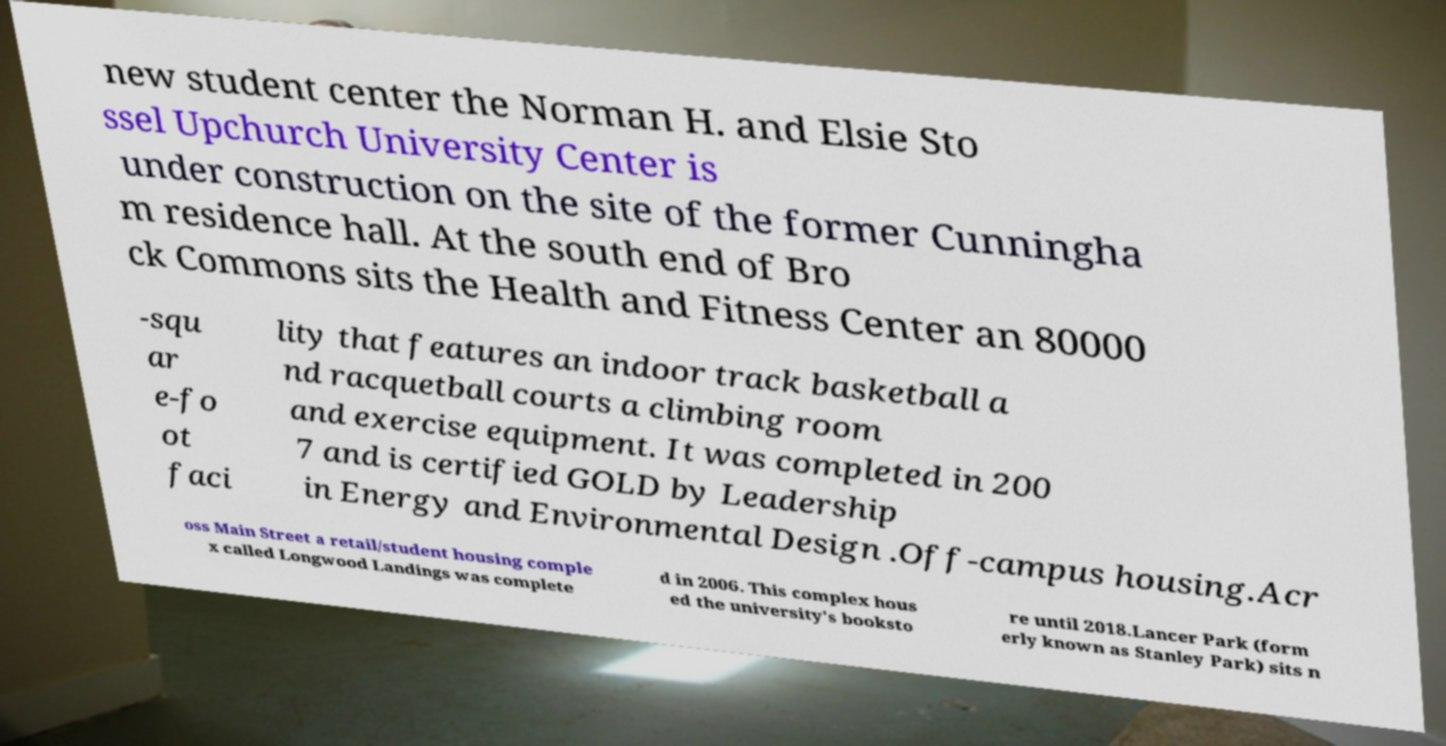Please read and relay the text visible in this image. What does it say? new student center the Norman H. and Elsie Sto ssel Upchurch University Center is under construction on the site of the former Cunningha m residence hall. At the south end of Bro ck Commons sits the Health and Fitness Center an 80000 -squ ar e-fo ot faci lity that features an indoor track basketball a nd racquetball courts a climbing room and exercise equipment. It was completed in 200 7 and is certified GOLD by Leadership in Energy and Environmental Design .Off-campus housing.Acr oss Main Street a retail/student housing comple x called Longwood Landings was complete d in 2006. This complex hous ed the university's booksto re until 2018.Lancer Park (form erly known as Stanley Park) sits n 